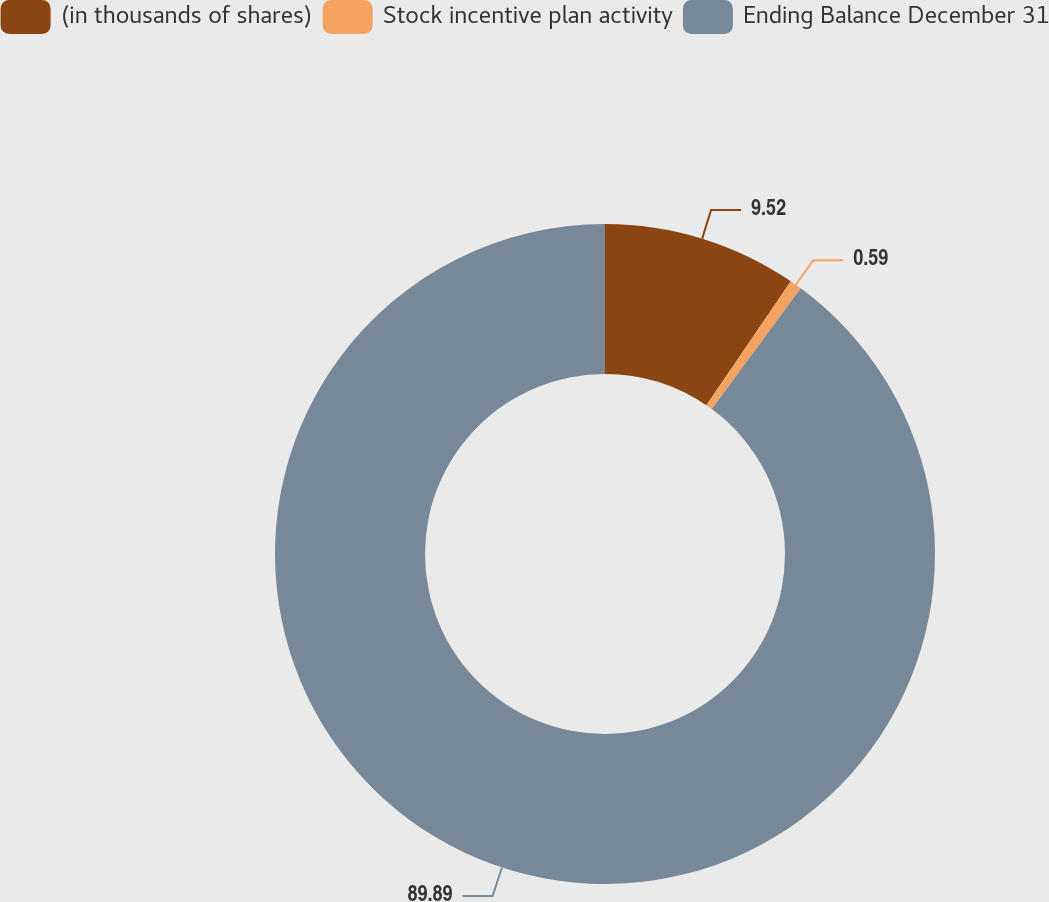<chart> <loc_0><loc_0><loc_500><loc_500><pie_chart><fcel>(in thousands of shares)<fcel>Stock incentive plan activity<fcel>Ending Balance December 31<nl><fcel>9.52%<fcel>0.59%<fcel>89.9%<nl></chart> 